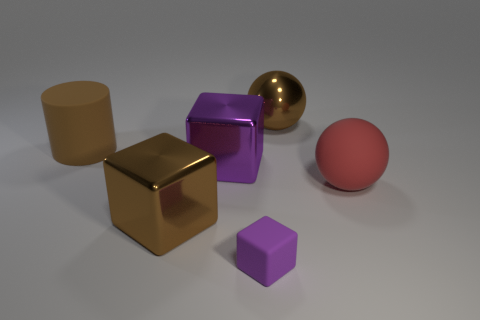Do the matte thing left of the brown metallic cube and the shiny object behind the matte cylinder have the same size?
Your answer should be compact. Yes. There is a block in front of the brown shiny thing that is on the left side of the large object behind the brown matte object; what is its color?
Offer a very short reply. Purple. Are there any large yellow rubber objects of the same shape as the red object?
Provide a succinct answer. No. Is the number of metal blocks that are in front of the matte ball greater than the number of large red matte spheres?
Provide a succinct answer. No. What number of matte objects are either big brown cubes or cylinders?
Make the answer very short. 1. There is a object that is in front of the large rubber cylinder and right of the tiny cube; what size is it?
Your response must be concise. Large. Are there any large brown shiny blocks to the left of the brown rubber thing that is behind the big brown block?
Your answer should be very brief. No. There is a big purple object; how many large brown shiny things are in front of it?
Provide a short and direct response. 1. What color is the small object that is the same shape as the large purple object?
Your answer should be very brief. Purple. Is the material of the large cube that is to the left of the big purple metallic cube the same as the purple thing behind the small object?
Provide a succinct answer. Yes. 